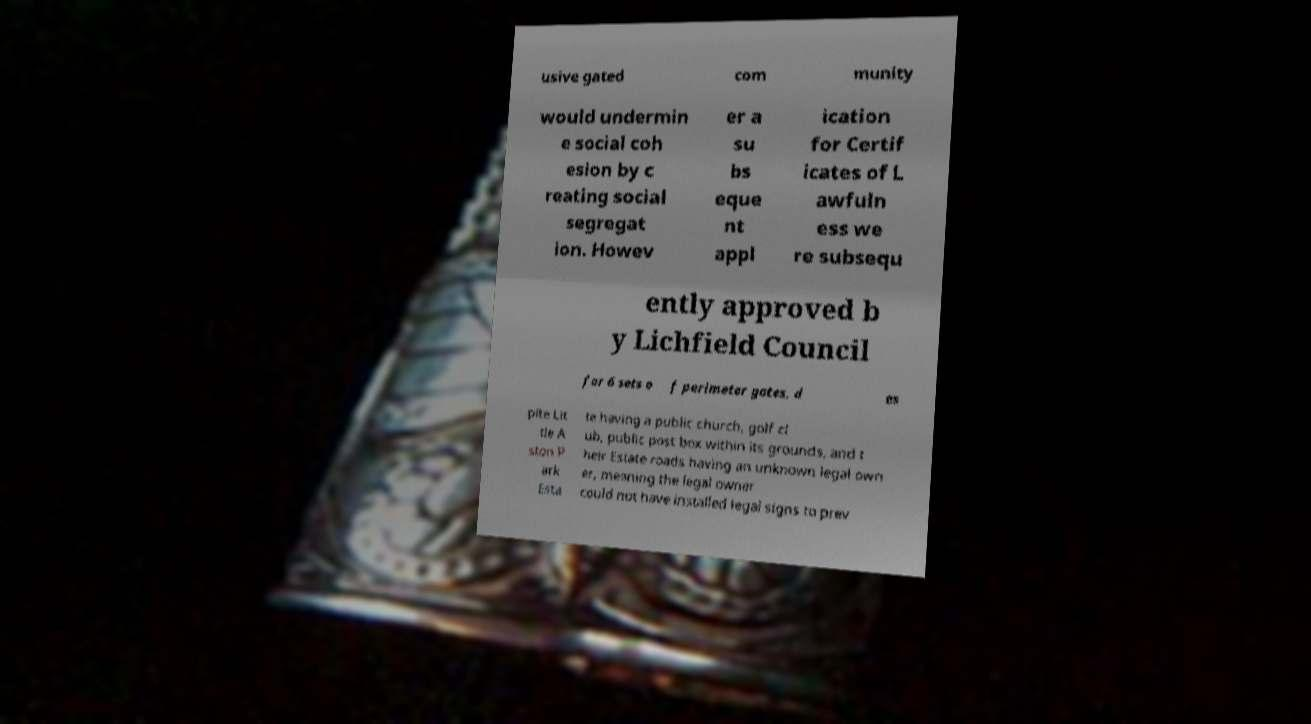Please read and relay the text visible in this image. What does it say? usive gated com munity would undermin e social coh esion by c reating social segregat ion. Howev er a su bs eque nt appl ication for Certif icates of L awfuln ess we re subsequ ently approved b y Lichfield Council for 6 sets o f perimeter gates, d es pite Lit tle A ston P ark Esta te having a public church, golf cl ub, public post box within its grounds, and t heir Estate roads having an unknown legal own er, meaning the legal owner could not have installed legal signs to prev 